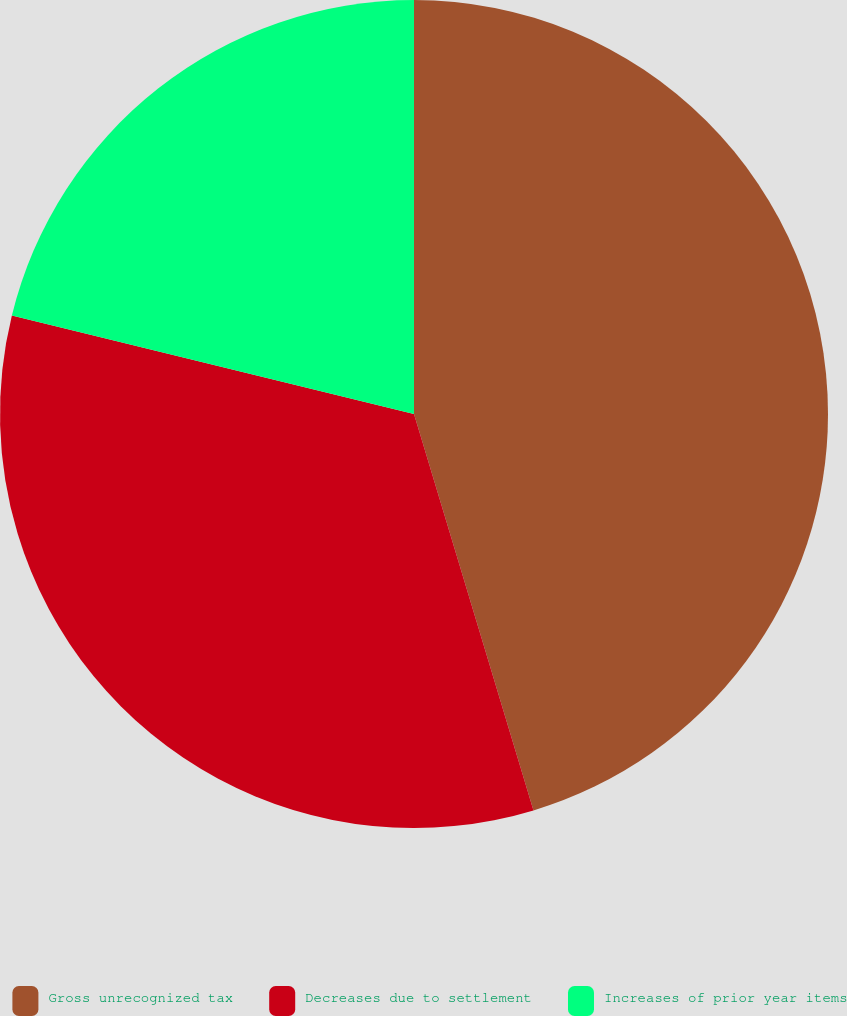<chart> <loc_0><loc_0><loc_500><loc_500><pie_chart><fcel>Gross unrecognized tax<fcel>Decreases due to settlement<fcel>Increases of prior year items<nl><fcel>45.34%<fcel>33.48%<fcel>21.18%<nl></chart> 